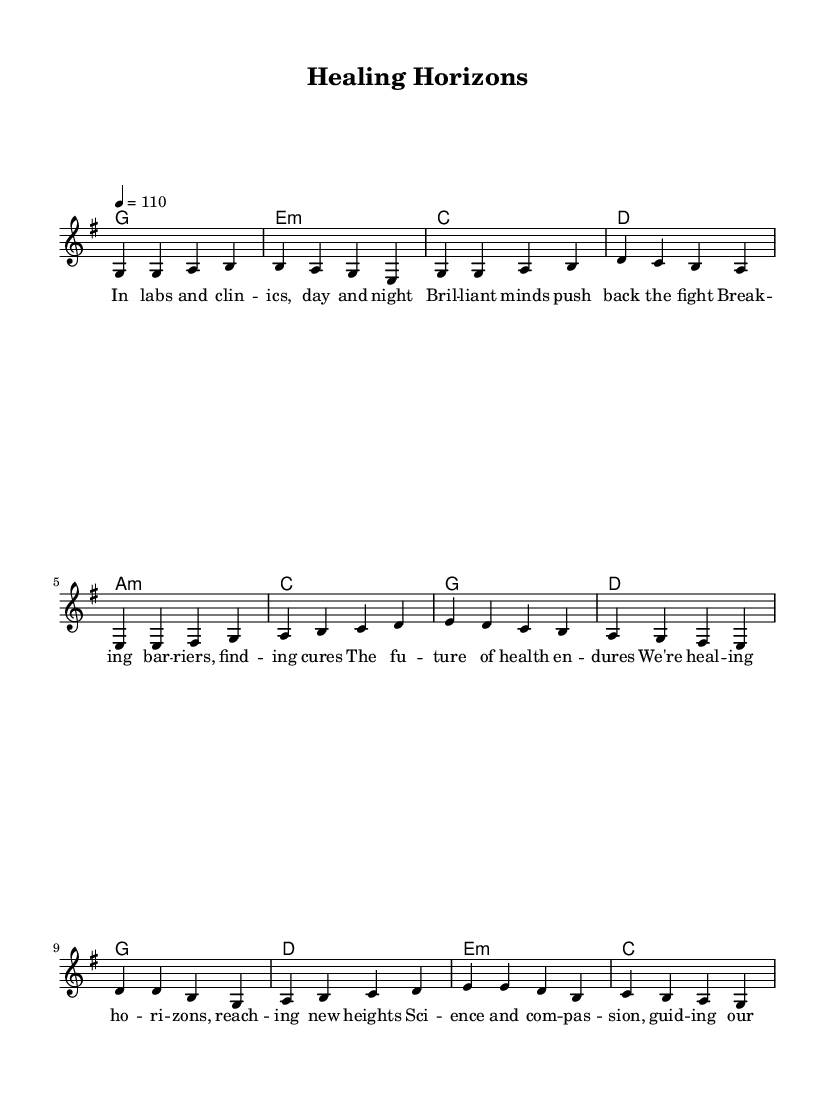What is the key signature of this music? The key signature is G major, which has one sharp (F#). This can be determined by observing the key signature notation at the beginning of the score.
Answer: G major What is the time signature of this piece? The time signature is 4/4, indicating that there are four beats in each measure and a quarter note receives one beat. This is visible right at the beginning of the score where the time signature is notated.
Answer: 4/4 What is the tempo marking? The tempo marking is 110 beats per minute. This is stated in the tempo directive in the score, indicating how fast the piece should be played.
Answer: 110 What is the first chord used in the verse? The first chord in the verse is G major, which is identified in the chord changes written above the melody. The chord is in the first measure of the verse section.
Answer: G How many measures are in the verse section? There are four measures in the verse section. This can be counted by looking at the segments between the vertical bar lines in the score.
Answer: 4 What emotion does the chorus convey? The chorus conveys hope and resilience, as reflected in the lyrics which speak about healing horizons and a positive influence of science and compassion. This is derived from the overall sentiment expressed through the lyrics and musical structure.
Answer: Hope Which musical section follows the verse? The pre-chorus follows the verse, as indicated by the sequence of lyrics and corresponding chord changes in the score. The structure of the song is clearly defined with the verses, followed by the pre-chorus, and then the chorus.
Answer: Pre-chorus 